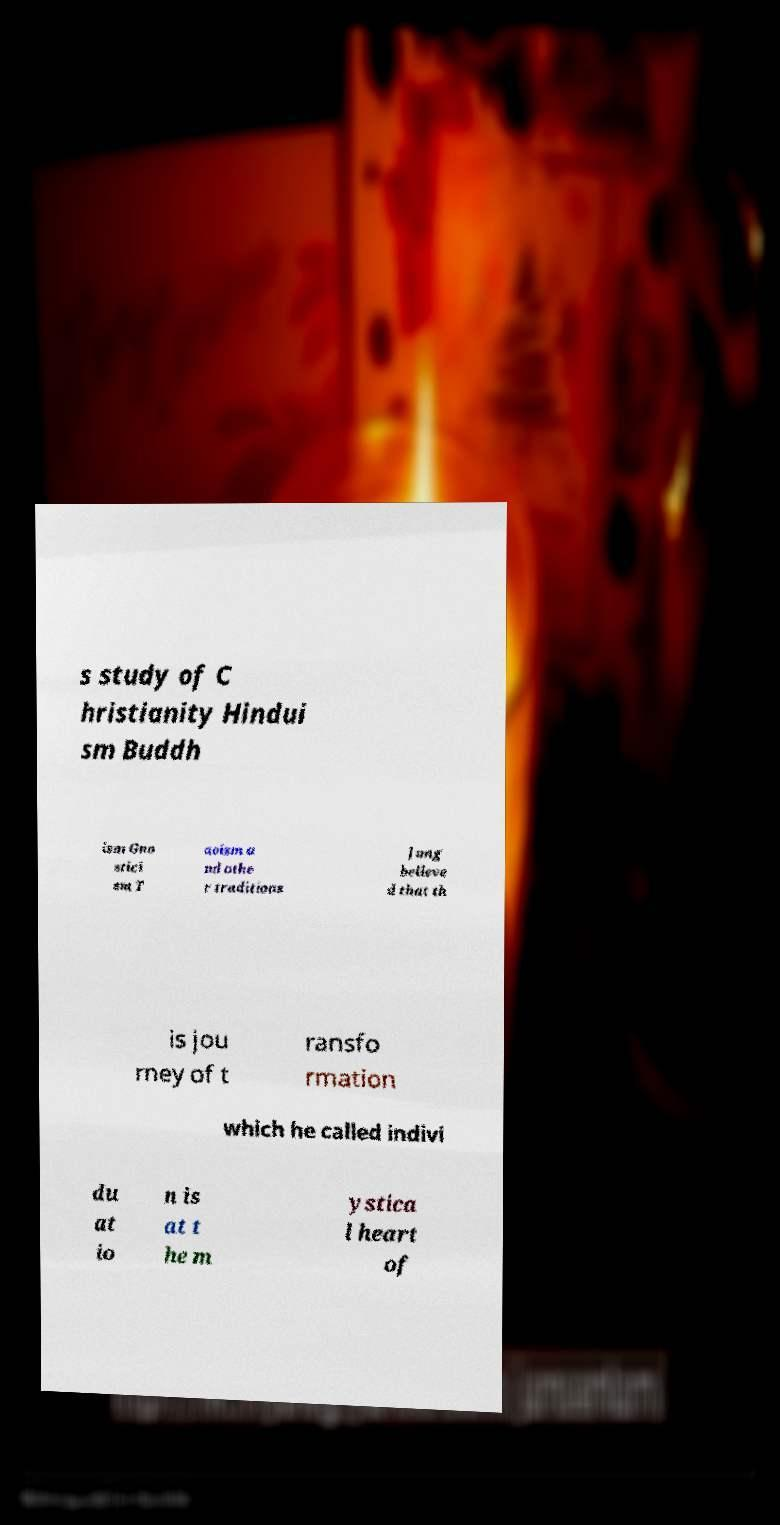Please identify and transcribe the text found in this image. s study of C hristianity Hindui sm Buddh ism Gno stici sm T aoism a nd othe r traditions Jung believe d that th is jou rney of t ransfo rmation which he called indivi du at io n is at t he m ystica l heart of 